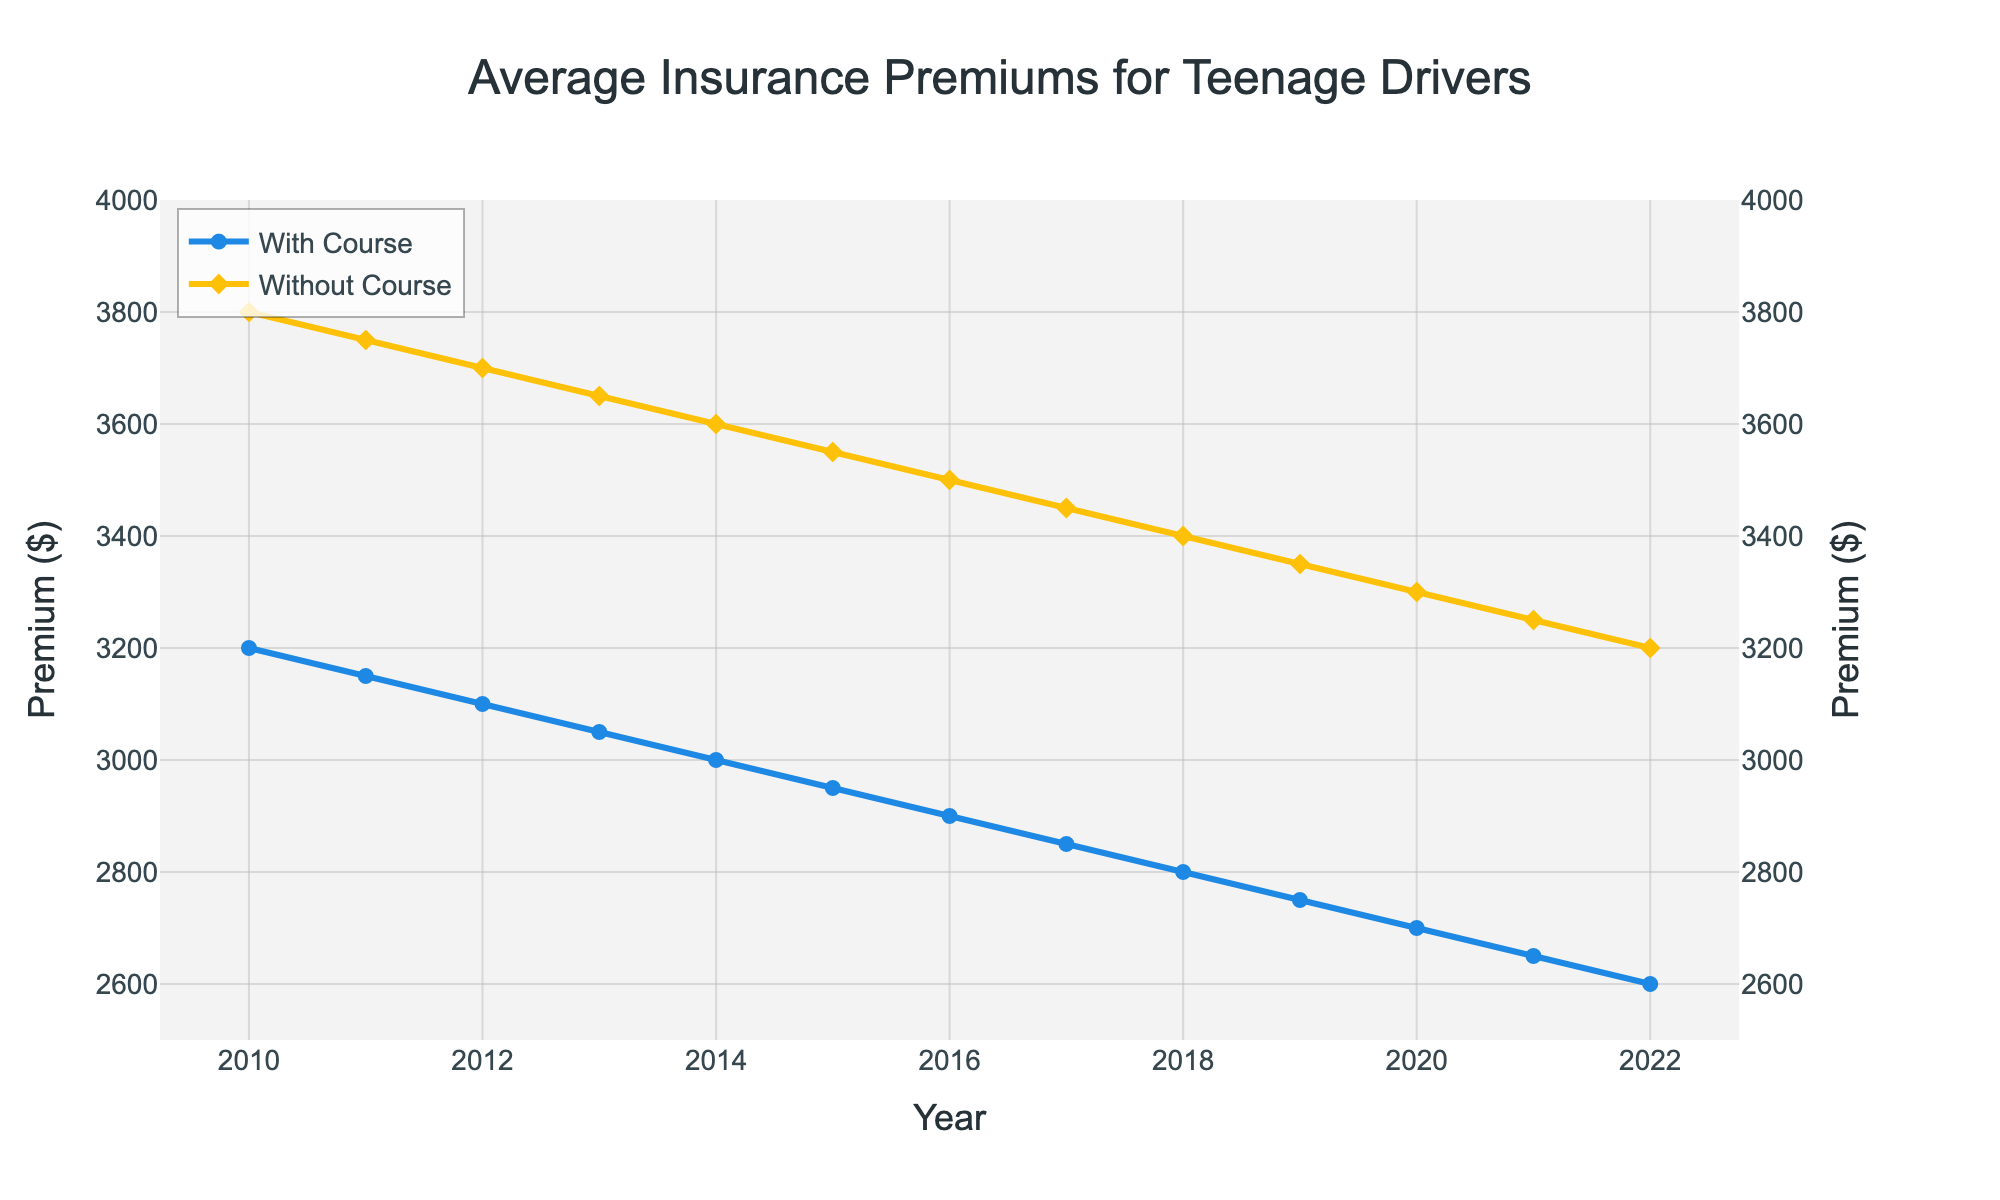What trend do you notice in the premiums for teenage drivers who completed the course over the years? From 2010 to 2022, the average insurance premiums for teenage drivers who completed the defensive driving course consistently decreased from $3200 to $2600.
Answer: Decreasing trend What is the difference in premiums between drivers who completed and did not complete the course in 2022? In 2022, the premium for drivers who completed the course was $2600, and for those who did not, it was $3200. The difference is $3200 - $2600 = $600.
Answer: $600 How much did the premiums for drivers without the course decrease from 2010 to 2022? In 2010, the premium for drivers without the course was $3800, and in 2022 it was $3200. The decrease is $3800 - $3200 = $600.
Answer: $600 In which year was the difference between the two groups' premiums the largest? To find the largest difference, compare the premium differences for each year. The difference is consistently $600 for all years from 2010 to 2022.
Answer: All years What was the average insurance premium for drivers who completed the course over the entire period? The yearly premiums for drivers who completed the course are [3200, 3150, 3100, 3050, 3000, 2950, 2900, 2850, 2800, 2750, 2700, 2650, 2600]. Sum these values and divide by 13: (3200 + 3150 + 3100 + 3050 + 3000 + 2950 + 2900 + 2850 + 2800 + 2750 + 2700 + 2650 + 2600) / 13 ≈ 2900.
Answer: ≈ $2900 What is the general relationship between premiums with and without the course each year from 2010 to 2022? Each year from 2010 to 2022, premiums for drivers who did not complete the course were consistently $600 higher than those for drivers who completed the course.
Answer: Higher by $600 each year In 2016, what was the percentage difference in premiums between drivers with and without the course? In 2016, premiums were $2900 with the course and $3500 without the course. Percentage difference is calculated as ((3500 - 2900) / 3500) * 100 = (600 / 3500) * 100 ≈ 17.14%.
Answer: ≈ 17.14% How did insurance premiums change from one year to the next for teenage drivers who completed the course? Each year, insurance premiums consistently decreased by $50 for drivers who completed the course. For example, in 2010 it was $3200, in 2011 it was $3150, and so on.
Answer: Decreased by $50 each year 